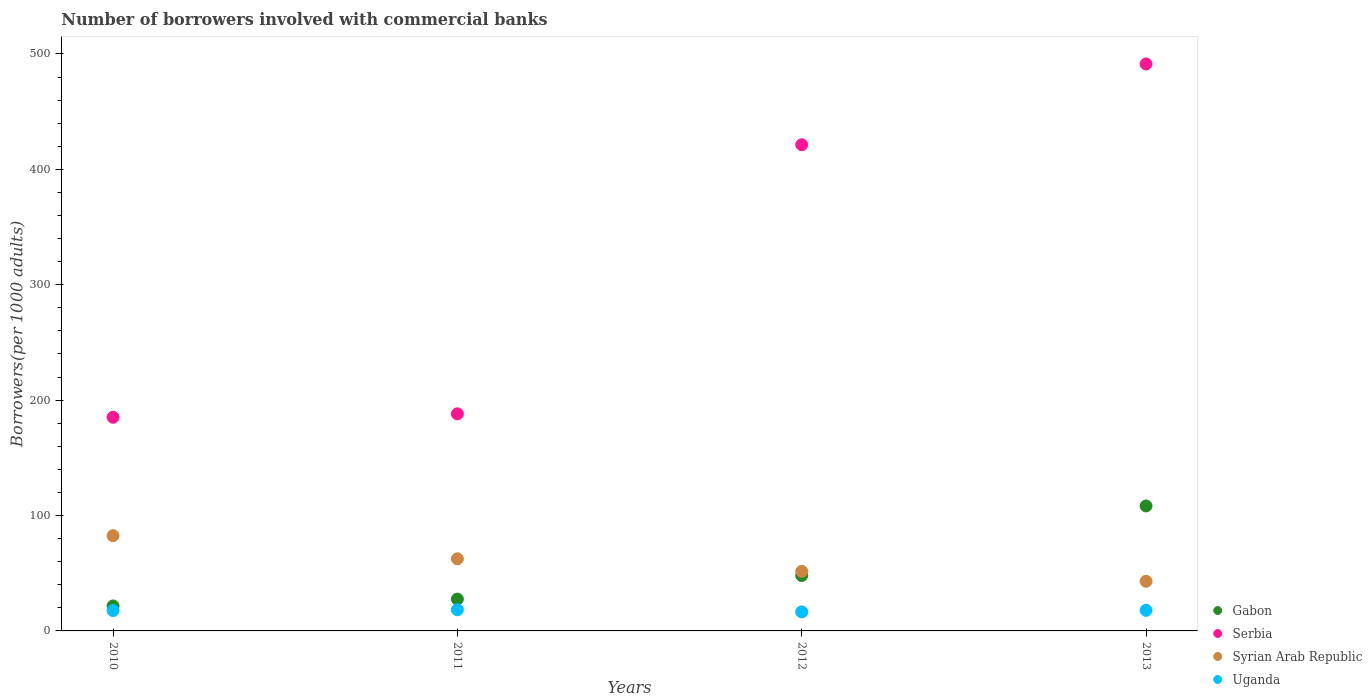Is the number of dotlines equal to the number of legend labels?
Ensure brevity in your answer.  Yes. What is the number of borrowers involved with commercial banks in Uganda in 2012?
Provide a succinct answer. 16.49. Across all years, what is the maximum number of borrowers involved with commercial banks in Serbia?
Provide a succinct answer. 491.32. Across all years, what is the minimum number of borrowers involved with commercial banks in Gabon?
Provide a short and direct response. 21.66. In which year was the number of borrowers involved with commercial banks in Syrian Arab Republic maximum?
Keep it short and to the point. 2010. What is the total number of borrowers involved with commercial banks in Serbia in the graph?
Offer a very short reply. 1285.88. What is the difference between the number of borrowers involved with commercial banks in Serbia in 2010 and that in 2012?
Ensure brevity in your answer.  -236.15. What is the difference between the number of borrowers involved with commercial banks in Syrian Arab Republic in 2011 and the number of borrowers involved with commercial banks in Gabon in 2010?
Provide a short and direct response. 40.84. What is the average number of borrowers involved with commercial banks in Syrian Arab Republic per year?
Give a very brief answer. 59.92. In the year 2013, what is the difference between the number of borrowers involved with commercial banks in Syrian Arab Republic and number of borrowers involved with commercial banks in Gabon?
Provide a succinct answer. -65.29. What is the ratio of the number of borrowers involved with commercial banks in Serbia in 2011 to that in 2013?
Ensure brevity in your answer.  0.38. What is the difference between the highest and the second highest number of borrowers involved with commercial banks in Serbia?
Your answer should be very brief. 70.01. What is the difference between the highest and the lowest number of borrowers involved with commercial banks in Uganda?
Give a very brief answer. 1.84. Is it the case that in every year, the sum of the number of borrowers involved with commercial banks in Uganda and number of borrowers involved with commercial banks in Gabon  is greater than the number of borrowers involved with commercial banks in Syrian Arab Republic?
Your answer should be compact. No. Does the number of borrowers involved with commercial banks in Syrian Arab Republic monotonically increase over the years?
Offer a very short reply. No. Is the number of borrowers involved with commercial banks in Syrian Arab Republic strictly greater than the number of borrowers involved with commercial banks in Serbia over the years?
Offer a terse response. No. Is the number of borrowers involved with commercial banks in Syrian Arab Republic strictly less than the number of borrowers involved with commercial banks in Serbia over the years?
Ensure brevity in your answer.  Yes. How many dotlines are there?
Ensure brevity in your answer.  4. What is the difference between two consecutive major ticks on the Y-axis?
Offer a very short reply. 100. Are the values on the major ticks of Y-axis written in scientific E-notation?
Give a very brief answer. No. Does the graph contain any zero values?
Provide a succinct answer. No. Does the graph contain grids?
Your response must be concise. No. Where does the legend appear in the graph?
Your answer should be compact. Bottom right. How are the legend labels stacked?
Provide a short and direct response. Vertical. What is the title of the graph?
Offer a terse response. Number of borrowers involved with commercial banks. Does "Russian Federation" appear as one of the legend labels in the graph?
Offer a terse response. No. What is the label or title of the X-axis?
Offer a terse response. Years. What is the label or title of the Y-axis?
Give a very brief answer. Borrowers(per 1000 adults). What is the Borrowers(per 1000 adults) of Gabon in 2010?
Provide a short and direct response. 21.66. What is the Borrowers(per 1000 adults) of Serbia in 2010?
Offer a very short reply. 185.15. What is the Borrowers(per 1000 adults) of Syrian Arab Republic in 2010?
Your response must be concise. 82.52. What is the Borrowers(per 1000 adults) in Uganda in 2010?
Offer a terse response. 17.68. What is the Borrowers(per 1000 adults) in Gabon in 2011?
Give a very brief answer. 27.56. What is the Borrowers(per 1000 adults) in Serbia in 2011?
Your answer should be compact. 188.1. What is the Borrowers(per 1000 adults) of Syrian Arab Republic in 2011?
Your response must be concise. 62.5. What is the Borrowers(per 1000 adults) in Uganda in 2011?
Provide a short and direct response. 18.33. What is the Borrowers(per 1000 adults) of Gabon in 2012?
Keep it short and to the point. 48.02. What is the Borrowers(per 1000 adults) of Serbia in 2012?
Provide a short and direct response. 421.31. What is the Borrowers(per 1000 adults) in Syrian Arab Republic in 2012?
Offer a terse response. 51.65. What is the Borrowers(per 1000 adults) in Uganda in 2012?
Your answer should be compact. 16.49. What is the Borrowers(per 1000 adults) in Gabon in 2013?
Your answer should be very brief. 108.3. What is the Borrowers(per 1000 adults) of Serbia in 2013?
Offer a terse response. 491.32. What is the Borrowers(per 1000 adults) in Syrian Arab Republic in 2013?
Keep it short and to the point. 43.01. What is the Borrowers(per 1000 adults) of Uganda in 2013?
Ensure brevity in your answer.  17.84. Across all years, what is the maximum Borrowers(per 1000 adults) in Gabon?
Make the answer very short. 108.3. Across all years, what is the maximum Borrowers(per 1000 adults) in Serbia?
Offer a terse response. 491.32. Across all years, what is the maximum Borrowers(per 1000 adults) of Syrian Arab Republic?
Offer a very short reply. 82.52. Across all years, what is the maximum Borrowers(per 1000 adults) in Uganda?
Give a very brief answer. 18.33. Across all years, what is the minimum Borrowers(per 1000 adults) in Gabon?
Offer a terse response. 21.66. Across all years, what is the minimum Borrowers(per 1000 adults) of Serbia?
Your response must be concise. 185.15. Across all years, what is the minimum Borrowers(per 1000 adults) in Syrian Arab Republic?
Provide a short and direct response. 43.01. Across all years, what is the minimum Borrowers(per 1000 adults) of Uganda?
Keep it short and to the point. 16.49. What is the total Borrowers(per 1000 adults) in Gabon in the graph?
Provide a short and direct response. 205.53. What is the total Borrowers(per 1000 adults) of Serbia in the graph?
Make the answer very short. 1285.88. What is the total Borrowers(per 1000 adults) of Syrian Arab Republic in the graph?
Your answer should be very brief. 239.67. What is the total Borrowers(per 1000 adults) in Uganda in the graph?
Give a very brief answer. 70.34. What is the difference between the Borrowers(per 1000 adults) in Gabon in 2010 and that in 2011?
Provide a succinct answer. -5.9. What is the difference between the Borrowers(per 1000 adults) in Serbia in 2010 and that in 2011?
Provide a succinct answer. -2.94. What is the difference between the Borrowers(per 1000 adults) of Syrian Arab Republic in 2010 and that in 2011?
Your answer should be compact. 20.02. What is the difference between the Borrowers(per 1000 adults) in Uganda in 2010 and that in 2011?
Ensure brevity in your answer.  -0.66. What is the difference between the Borrowers(per 1000 adults) of Gabon in 2010 and that in 2012?
Offer a terse response. -26.36. What is the difference between the Borrowers(per 1000 adults) of Serbia in 2010 and that in 2012?
Make the answer very short. -236.15. What is the difference between the Borrowers(per 1000 adults) in Syrian Arab Republic in 2010 and that in 2012?
Your response must be concise. 30.87. What is the difference between the Borrowers(per 1000 adults) of Uganda in 2010 and that in 2012?
Make the answer very short. 1.18. What is the difference between the Borrowers(per 1000 adults) in Gabon in 2010 and that in 2013?
Ensure brevity in your answer.  -86.65. What is the difference between the Borrowers(per 1000 adults) of Serbia in 2010 and that in 2013?
Keep it short and to the point. -306.16. What is the difference between the Borrowers(per 1000 adults) of Syrian Arab Republic in 2010 and that in 2013?
Make the answer very short. 39.51. What is the difference between the Borrowers(per 1000 adults) of Uganda in 2010 and that in 2013?
Make the answer very short. -0.17. What is the difference between the Borrowers(per 1000 adults) in Gabon in 2011 and that in 2012?
Keep it short and to the point. -20.46. What is the difference between the Borrowers(per 1000 adults) in Serbia in 2011 and that in 2012?
Your response must be concise. -233.21. What is the difference between the Borrowers(per 1000 adults) of Syrian Arab Republic in 2011 and that in 2012?
Offer a very short reply. 10.85. What is the difference between the Borrowers(per 1000 adults) of Uganda in 2011 and that in 2012?
Provide a succinct answer. 1.84. What is the difference between the Borrowers(per 1000 adults) in Gabon in 2011 and that in 2013?
Ensure brevity in your answer.  -80.74. What is the difference between the Borrowers(per 1000 adults) of Serbia in 2011 and that in 2013?
Your response must be concise. -303.22. What is the difference between the Borrowers(per 1000 adults) of Syrian Arab Republic in 2011 and that in 2013?
Ensure brevity in your answer.  19.49. What is the difference between the Borrowers(per 1000 adults) in Uganda in 2011 and that in 2013?
Ensure brevity in your answer.  0.49. What is the difference between the Borrowers(per 1000 adults) in Gabon in 2012 and that in 2013?
Your answer should be very brief. -60.28. What is the difference between the Borrowers(per 1000 adults) of Serbia in 2012 and that in 2013?
Offer a very short reply. -70.01. What is the difference between the Borrowers(per 1000 adults) in Syrian Arab Republic in 2012 and that in 2013?
Offer a very short reply. 8.63. What is the difference between the Borrowers(per 1000 adults) of Uganda in 2012 and that in 2013?
Give a very brief answer. -1.35. What is the difference between the Borrowers(per 1000 adults) in Gabon in 2010 and the Borrowers(per 1000 adults) in Serbia in 2011?
Offer a terse response. -166.44. What is the difference between the Borrowers(per 1000 adults) in Gabon in 2010 and the Borrowers(per 1000 adults) in Syrian Arab Republic in 2011?
Offer a terse response. -40.84. What is the difference between the Borrowers(per 1000 adults) in Gabon in 2010 and the Borrowers(per 1000 adults) in Uganda in 2011?
Ensure brevity in your answer.  3.32. What is the difference between the Borrowers(per 1000 adults) in Serbia in 2010 and the Borrowers(per 1000 adults) in Syrian Arab Republic in 2011?
Your answer should be very brief. 122.66. What is the difference between the Borrowers(per 1000 adults) of Serbia in 2010 and the Borrowers(per 1000 adults) of Uganda in 2011?
Keep it short and to the point. 166.82. What is the difference between the Borrowers(per 1000 adults) in Syrian Arab Republic in 2010 and the Borrowers(per 1000 adults) in Uganda in 2011?
Give a very brief answer. 64.19. What is the difference between the Borrowers(per 1000 adults) in Gabon in 2010 and the Borrowers(per 1000 adults) in Serbia in 2012?
Provide a short and direct response. -399.65. What is the difference between the Borrowers(per 1000 adults) in Gabon in 2010 and the Borrowers(per 1000 adults) in Syrian Arab Republic in 2012?
Your answer should be compact. -29.99. What is the difference between the Borrowers(per 1000 adults) of Gabon in 2010 and the Borrowers(per 1000 adults) of Uganda in 2012?
Give a very brief answer. 5.16. What is the difference between the Borrowers(per 1000 adults) in Serbia in 2010 and the Borrowers(per 1000 adults) in Syrian Arab Republic in 2012?
Ensure brevity in your answer.  133.51. What is the difference between the Borrowers(per 1000 adults) of Serbia in 2010 and the Borrowers(per 1000 adults) of Uganda in 2012?
Make the answer very short. 168.66. What is the difference between the Borrowers(per 1000 adults) of Syrian Arab Republic in 2010 and the Borrowers(per 1000 adults) of Uganda in 2012?
Give a very brief answer. 66.03. What is the difference between the Borrowers(per 1000 adults) in Gabon in 2010 and the Borrowers(per 1000 adults) in Serbia in 2013?
Your answer should be compact. -469.66. What is the difference between the Borrowers(per 1000 adults) of Gabon in 2010 and the Borrowers(per 1000 adults) of Syrian Arab Republic in 2013?
Keep it short and to the point. -21.36. What is the difference between the Borrowers(per 1000 adults) of Gabon in 2010 and the Borrowers(per 1000 adults) of Uganda in 2013?
Offer a very short reply. 3.81. What is the difference between the Borrowers(per 1000 adults) of Serbia in 2010 and the Borrowers(per 1000 adults) of Syrian Arab Republic in 2013?
Make the answer very short. 142.14. What is the difference between the Borrowers(per 1000 adults) in Serbia in 2010 and the Borrowers(per 1000 adults) in Uganda in 2013?
Offer a very short reply. 167.31. What is the difference between the Borrowers(per 1000 adults) of Syrian Arab Republic in 2010 and the Borrowers(per 1000 adults) of Uganda in 2013?
Your response must be concise. 64.68. What is the difference between the Borrowers(per 1000 adults) in Gabon in 2011 and the Borrowers(per 1000 adults) in Serbia in 2012?
Provide a short and direct response. -393.75. What is the difference between the Borrowers(per 1000 adults) in Gabon in 2011 and the Borrowers(per 1000 adults) in Syrian Arab Republic in 2012?
Make the answer very short. -24.09. What is the difference between the Borrowers(per 1000 adults) of Gabon in 2011 and the Borrowers(per 1000 adults) of Uganda in 2012?
Provide a succinct answer. 11.07. What is the difference between the Borrowers(per 1000 adults) of Serbia in 2011 and the Borrowers(per 1000 adults) of Syrian Arab Republic in 2012?
Provide a succinct answer. 136.45. What is the difference between the Borrowers(per 1000 adults) of Serbia in 2011 and the Borrowers(per 1000 adults) of Uganda in 2012?
Keep it short and to the point. 171.61. What is the difference between the Borrowers(per 1000 adults) in Syrian Arab Republic in 2011 and the Borrowers(per 1000 adults) in Uganda in 2012?
Provide a short and direct response. 46.01. What is the difference between the Borrowers(per 1000 adults) in Gabon in 2011 and the Borrowers(per 1000 adults) in Serbia in 2013?
Offer a very short reply. -463.76. What is the difference between the Borrowers(per 1000 adults) of Gabon in 2011 and the Borrowers(per 1000 adults) of Syrian Arab Republic in 2013?
Provide a succinct answer. -15.45. What is the difference between the Borrowers(per 1000 adults) of Gabon in 2011 and the Borrowers(per 1000 adults) of Uganda in 2013?
Your answer should be very brief. 9.72. What is the difference between the Borrowers(per 1000 adults) in Serbia in 2011 and the Borrowers(per 1000 adults) in Syrian Arab Republic in 2013?
Give a very brief answer. 145.09. What is the difference between the Borrowers(per 1000 adults) in Serbia in 2011 and the Borrowers(per 1000 adults) in Uganda in 2013?
Offer a terse response. 170.26. What is the difference between the Borrowers(per 1000 adults) in Syrian Arab Republic in 2011 and the Borrowers(per 1000 adults) in Uganda in 2013?
Offer a very short reply. 44.66. What is the difference between the Borrowers(per 1000 adults) in Gabon in 2012 and the Borrowers(per 1000 adults) in Serbia in 2013?
Provide a succinct answer. -443.3. What is the difference between the Borrowers(per 1000 adults) of Gabon in 2012 and the Borrowers(per 1000 adults) of Syrian Arab Republic in 2013?
Provide a short and direct response. 5. What is the difference between the Borrowers(per 1000 adults) in Gabon in 2012 and the Borrowers(per 1000 adults) in Uganda in 2013?
Your answer should be compact. 30.18. What is the difference between the Borrowers(per 1000 adults) in Serbia in 2012 and the Borrowers(per 1000 adults) in Syrian Arab Republic in 2013?
Offer a terse response. 378.3. What is the difference between the Borrowers(per 1000 adults) in Serbia in 2012 and the Borrowers(per 1000 adults) in Uganda in 2013?
Offer a very short reply. 403.47. What is the difference between the Borrowers(per 1000 adults) in Syrian Arab Republic in 2012 and the Borrowers(per 1000 adults) in Uganda in 2013?
Make the answer very short. 33.8. What is the average Borrowers(per 1000 adults) of Gabon per year?
Give a very brief answer. 51.38. What is the average Borrowers(per 1000 adults) of Serbia per year?
Provide a short and direct response. 321.47. What is the average Borrowers(per 1000 adults) of Syrian Arab Republic per year?
Your response must be concise. 59.92. What is the average Borrowers(per 1000 adults) of Uganda per year?
Offer a terse response. 17.59. In the year 2010, what is the difference between the Borrowers(per 1000 adults) of Gabon and Borrowers(per 1000 adults) of Serbia?
Make the answer very short. -163.5. In the year 2010, what is the difference between the Borrowers(per 1000 adults) of Gabon and Borrowers(per 1000 adults) of Syrian Arab Republic?
Give a very brief answer. -60.86. In the year 2010, what is the difference between the Borrowers(per 1000 adults) in Gabon and Borrowers(per 1000 adults) in Uganda?
Ensure brevity in your answer.  3.98. In the year 2010, what is the difference between the Borrowers(per 1000 adults) of Serbia and Borrowers(per 1000 adults) of Syrian Arab Republic?
Ensure brevity in your answer.  102.64. In the year 2010, what is the difference between the Borrowers(per 1000 adults) in Serbia and Borrowers(per 1000 adults) in Uganda?
Your answer should be compact. 167.48. In the year 2010, what is the difference between the Borrowers(per 1000 adults) in Syrian Arab Republic and Borrowers(per 1000 adults) in Uganda?
Your answer should be very brief. 64.84. In the year 2011, what is the difference between the Borrowers(per 1000 adults) of Gabon and Borrowers(per 1000 adults) of Serbia?
Give a very brief answer. -160.54. In the year 2011, what is the difference between the Borrowers(per 1000 adults) of Gabon and Borrowers(per 1000 adults) of Syrian Arab Republic?
Keep it short and to the point. -34.94. In the year 2011, what is the difference between the Borrowers(per 1000 adults) in Gabon and Borrowers(per 1000 adults) in Uganda?
Offer a very short reply. 9.23. In the year 2011, what is the difference between the Borrowers(per 1000 adults) of Serbia and Borrowers(per 1000 adults) of Syrian Arab Republic?
Your answer should be compact. 125.6. In the year 2011, what is the difference between the Borrowers(per 1000 adults) of Serbia and Borrowers(per 1000 adults) of Uganda?
Ensure brevity in your answer.  169.77. In the year 2011, what is the difference between the Borrowers(per 1000 adults) of Syrian Arab Republic and Borrowers(per 1000 adults) of Uganda?
Your answer should be very brief. 44.17. In the year 2012, what is the difference between the Borrowers(per 1000 adults) of Gabon and Borrowers(per 1000 adults) of Serbia?
Your answer should be very brief. -373.29. In the year 2012, what is the difference between the Borrowers(per 1000 adults) of Gabon and Borrowers(per 1000 adults) of Syrian Arab Republic?
Offer a terse response. -3.63. In the year 2012, what is the difference between the Borrowers(per 1000 adults) in Gabon and Borrowers(per 1000 adults) in Uganda?
Your response must be concise. 31.53. In the year 2012, what is the difference between the Borrowers(per 1000 adults) of Serbia and Borrowers(per 1000 adults) of Syrian Arab Republic?
Your response must be concise. 369.66. In the year 2012, what is the difference between the Borrowers(per 1000 adults) in Serbia and Borrowers(per 1000 adults) in Uganda?
Offer a terse response. 404.82. In the year 2012, what is the difference between the Borrowers(per 1000 adults) of Syrian Arab Republic and Borrowers(per 1000 adults) of Uganda?
Keep it short and to the point. 35.15. In the year 2013, what is the difference between the Borrowers(per 1000 adults) in Gabon and Borrowers(per 1000 adults) in Serbia?
Give a very brief answer. -383.01. In the year 2013, what is the difference between the Borrowers(per 1000 adults) of Gabon and Borrowers(per 1000 adults) of Syrian Arab Republic?
Give a very brief answer. 65.29. In the year 2013, what is the difference between the Borrowers(per 1000 adults) in Gabon and Borrowers(per 1000 adults) in Uganda?
Your response must be concise. 90.46. In the year 2013, what is the difference between the Borrowers(per 1000 adults) of Serbia and Borrowers(per 1000 adults) of Syrian Arab Republic?
Your answer should be compact. 448.3. In the year 2013, what is the difference between the Borrowers(per 1000 adults) in Serbia and Borrowers(per 1000 adults) in Uganda?
Provide a short and direct response. 473.47. In the year 2013, what is the difference between the Borrowers(per 1000 adults) in Syrian Arab Republic and Borrowers(per 1000 adults) in Uganda?
Provide a succinct answer. 25.17. What is the ratio of the Borrowers(per 1000 adults) in Gabon in 2010 to that in 2011?
Provide a succinct answer. 0.79. What is the ratio of the Borrowers(per 1000 adults) of Serbia in 2010 to that in 2011?
Give a very brief answer. 0.98. What is the ratio of the Borrowers(per 1000 adults) in Syrian Arab Republic in 2010 to that in 2011?
Your answer should be compact. 1.32. What is the ratio of the Borrowers(per 1000 adults) of Uganda in 2010 to that in 2011?
Your response must be concise. 0.96. What is the ratio of the Borrowers(per 1000 adults) of Gabon in 2010 to that in 2012?
Your response must be concise. 0.45. What is the ratio of the Borrowers(per 1000 adults) in Serbia in 2010 to that in 2012?
Your answer should be very brief. 0.44. What is the ratio of the Borrowers(per 1000 adults) in Syrian Arab Republic in 2010 to that in 2012?
Keep it short and to the point. 1.6. What is the ratio of the Borrowers(per 1000 adults) in Uganda in 2010 to that in 2012?
Your response must be concise. 1.07. What is the ratio of the Borrowers(per 1000 adults) of Gabon in 2010 to that in 2013?
Provide a short and direct response. 0.2. What is the ratio of the Borrowers(per 1000 adults) in Serbia in 2010 to that in 2013?
Give a very brief answer. 0.38. What is the ratio of the Borrowers(per 1000 adults) in Syrian Arab Republic in 2010 to that in 2013?
Ensure brevity in your answer.  1.92. What is the ratio of the Borrowers(per 1000 adults) in Gabon in 2011 to that in 2012?
Make the answer very short. 0.57. What is the ratio of the Borrowers(per 1000 adults) in Serbia in 2011 to that in 2012?
Your answer should be very brief. 0.45. What is the ratio of the Borrowers(per 1000 adults) in Syrian Arab Republic in 2011 to that in 2012?
Offer a terse response. 1.21. What is the ratio of the Borrowers(per 1000 adults) of Uganda in 2011 to that in 2012?
Your response must be concise. 1.11. What is the ratio of the Borrowers(per 1000 adults) in Gabon in 2011 to that in 2013?
Your answer should be compact. 0.25. What is the ratio of the Borrowers(per 1000 adults) of Serbia in 2011 to that in 2013?
Give a very brief answer. 0.38. What is the ratio of the Borrowers(per 1000 adults) of Syrian Arab Republic in 2011 to that in 2013?
Give a very brief answer. 1.45. What is the ratio of the Borrowers(per 1000 adults) in Uganda in 2011 to that in 2013?
Your answer should be very brief. 1.03. What is the ratio of the Borrowers(per 1000 adults) in Gabon in 2012 to that in 2013?
Your answer should be very brief. 0.44. What is the ratio of the Borrowers(per 1000 adults) in Serbia in 2012 to that in 2013?
Provide a succinct answer. 0.86. What is the ratio of the Borrowers(per 1000 adults) in Syrian Arab Republic in 2012 to that in 2013?
Offer a terse response. 1.2. What is the ratio of the Borrowers(per 1000 adults) in Uganda in 2012 to that in 2013?
Your answer should be compact. 0.92. What is the difference between the highest and the second highest Borrowers(per 1000 adults) of Gabon?
Your response must be concise. 60.28. What is the difference between the highest and the second highest Borrowers(per 1000 adults) of Serbia?
Offer a terse response. 70.01. What is the difference between the highest and the second highest Borrowers(per 1000 adults) in Syrian Arab Republic?
Your answer should be compact. 20.02. What is the difference between the highest and the second highest Borrowers(per 1000 adults) in Uganda?
Give a very brief answer. 0.49. What is the difference between the highest and the lowest Borrowers(per 1000 adults) of Gabon?
Keep it short and to the point. 86.65. What is the difference between the highest and the lowest Borrowers(per 1000 adults) of Serbia?
Offer a very short reply. 306.16. What is the difference between the highest and the lowest Borrowers(per 1000 adults) in Syrian Arab Republic?
Your answer should be very brief. 39.51. What is the difference between the highest and the lowest Borrowers(per 1000 adults) in Uganda?
Your answer should be compact. 1.84. 